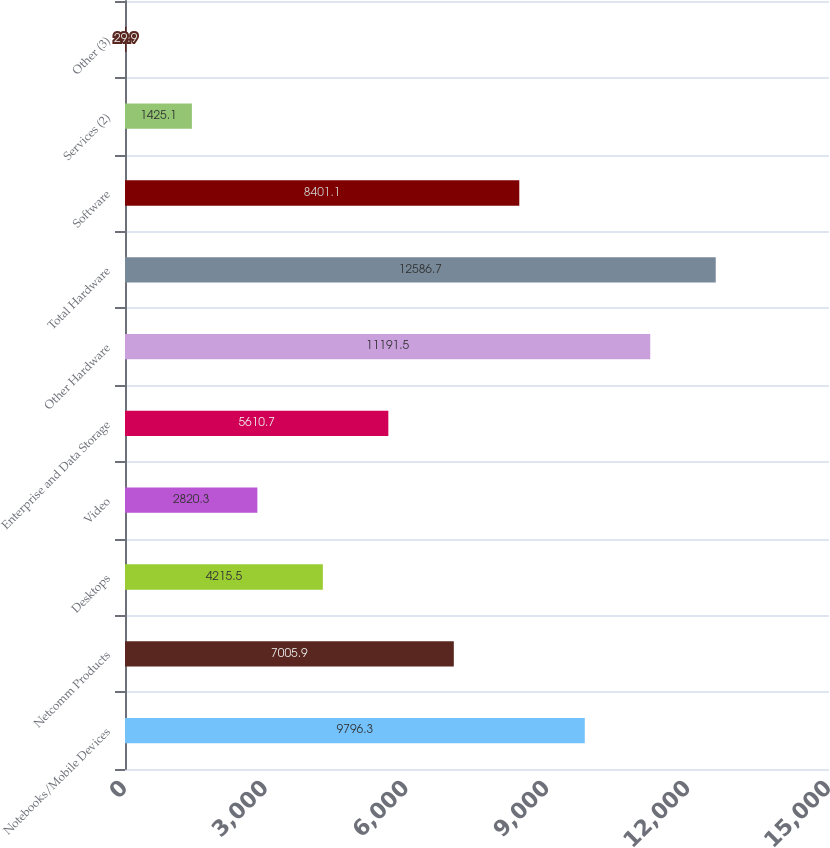Convert chart. <chart><loc_0><loc_0><loc_500><loc_500><bar_chart><fcel>Notebooks/Mobile Devices<fcel>Netcomm Products<fcel>Desktops<fcel>Video<fcel>Enterprise and Data Storage<fcel>Other Hardware<fcel>Total Hardware<fcel>Software<fcel>Services (2)<fcel>Other (3)<nl><fcel>9796.3<fcel>7005.9<fcel>4215.5<fcel>2820.3<fcel>5610.7<fcel>11191.5<fcel>12586.7<fcel>8401.1<fcel>1425.1<fcel>29.9<nl></chart> 